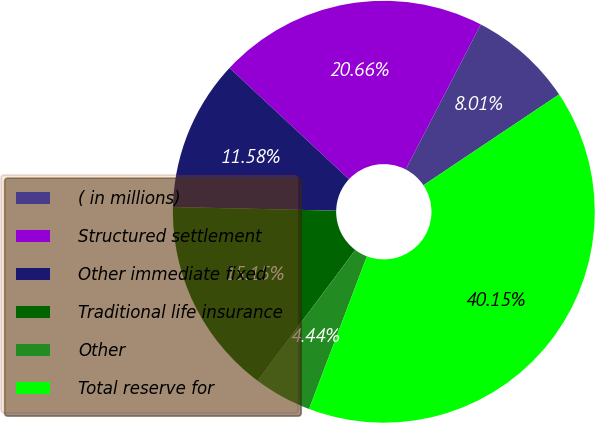<chart> <loc_0><loc_0><loc_500><loc_500><pie_chart><fcel>( in millions)<fcel>Structured settlement<fcel>Other immediate fixed<fcel>Traditional life insurance<fcel>Other<fcel>Total reserve for<nl><fcel>8.01%<fcel>20.66%<fcel>11.58%<fcel>15.15%<fcel>4.44%<fcel>40.15%<nl></chart> 